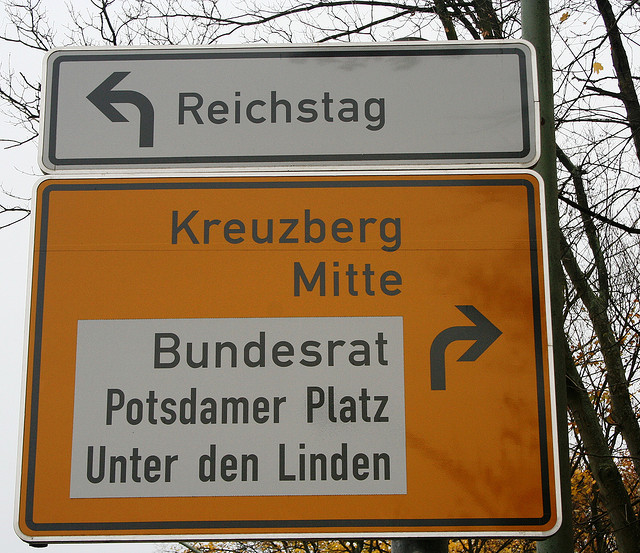Please extract the text content from this image. den Reichstag Kreuzberg Mitte Bundesrat Potsdamer Linden Unter Platz 